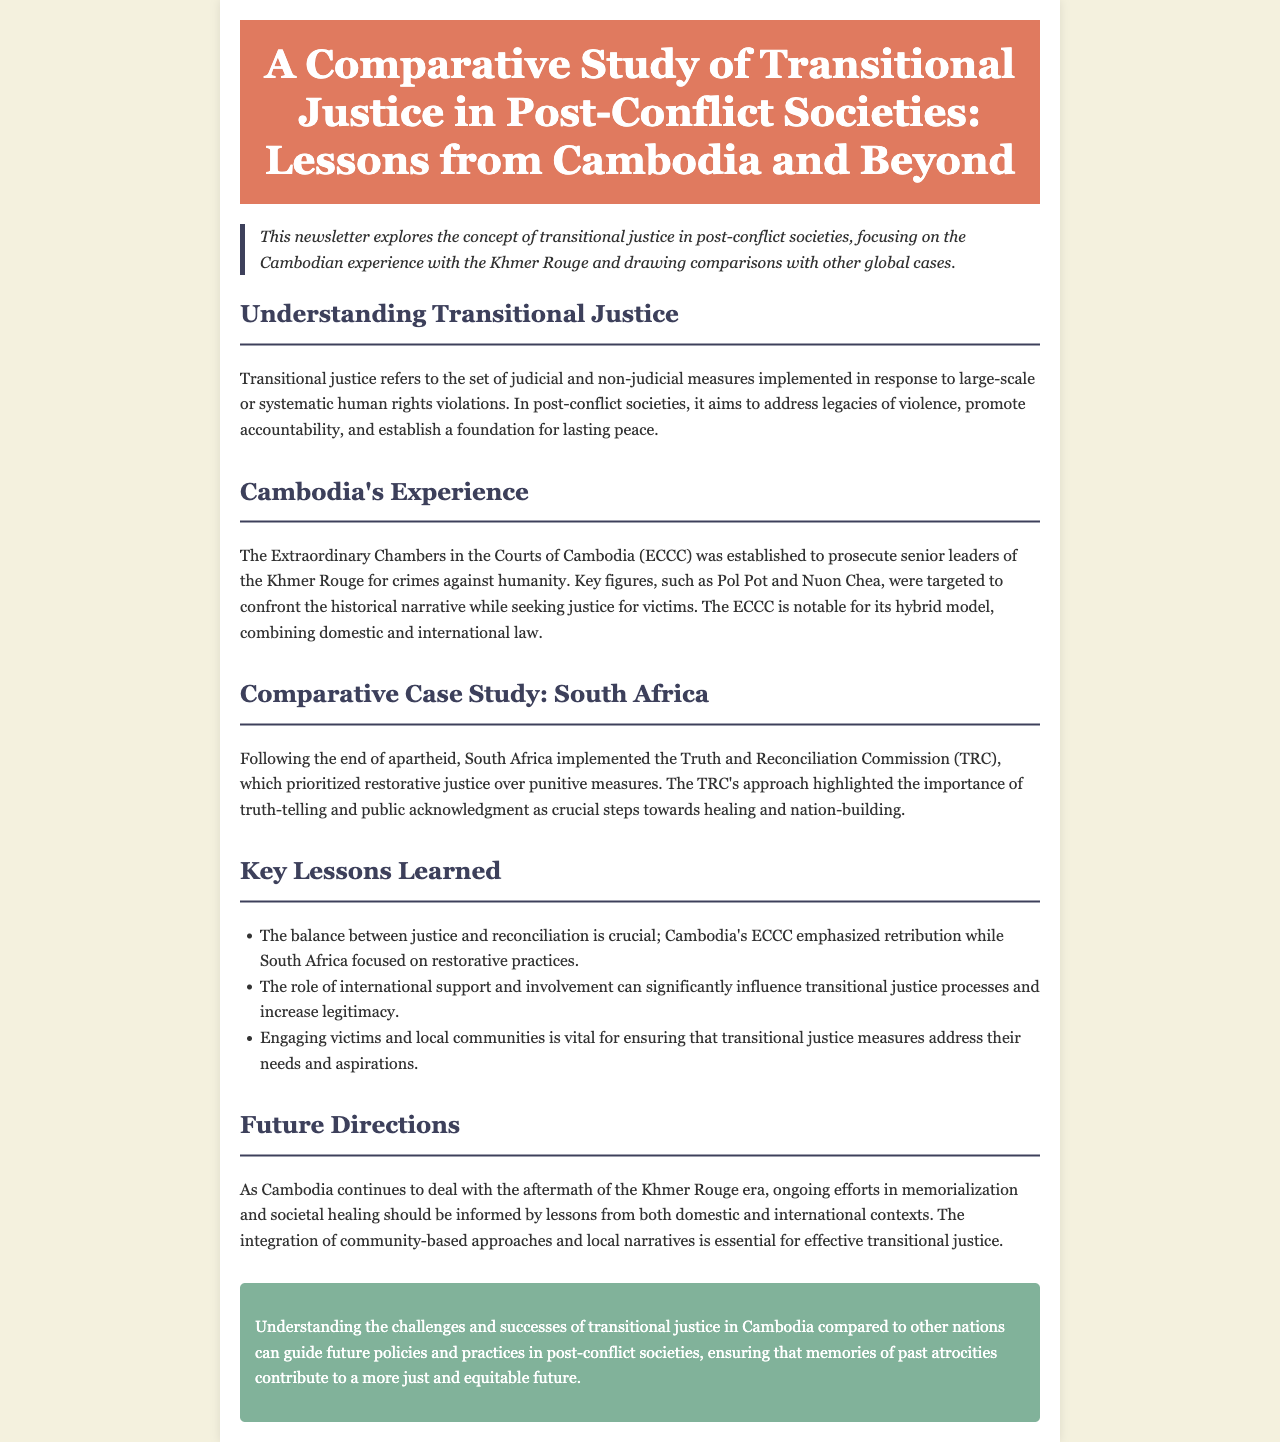what does transitional justice aim to address? Transitional justice aims to address legacies of violence, promote accountability, and establish a foundation for lasting peace.
Answer: legacies of violence, promote accountability, lasting peace who were the key figures prosecuted by the ECCC? The key figures prosecuted include Pol Pot and Nuon Chea, targeted to confront the historical narrative.
Answer: Pol Pot and Nuon Chea what commission did South Africa implement post-apartheid? South Africa implemented the Truth and Reconciliation Commission (TRC) post-apartheid.
Answer: Truth and Reconciliation Commission what is the focus of Cambodia's ECCC compared to South Africa's TRC? Cambodia's ECCC emphasized retribution, while South Africa's TRC focused on restorative practices.
Answer: retribution; restorative practices why is engaging local communities important in transitional justice? Engaging victims and local communities ensures that transitional justice measures address their needs and aspirations.
Answer: address their needs and aspirations what hybrid model does the ECCC utilize? The ECCC utilizes a hybrid model that combines domestic and international law.
Answer: hybrid model what lesson highlights the role of international involvement? The role of international support and involvement can significantly influence transitional justice processes and increase legitimacy.
Answer: influence transitional justice processes what should future efforts in Cambodia's transitional justice be informed by? Ongoing efforts in memorialization and societal healing should be informed by lessons from both domestic and international contexts.
Answer: lessons from both domestic and international contexts 